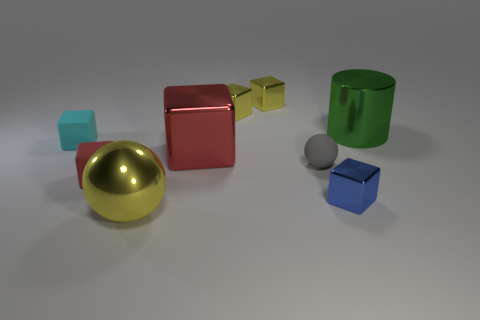There is a object that is the same color as the big cube; what shape is it?
Your answer should be compact. Cube. Is the number of red things that are on the right side of the green object less than the number of large green things in front of the tiny blue shiny object?
Your answer should be compact. No. What number of other objects are the same material as the green thing?
Ensure brevity in your answer.  5. Does the blue thing have the same material as the big green object?
Provide a short and direct response. Yes. How many other things are there of the same size as the gray thing?
Give a very brief answer. 5. What is the size of the red object that is in front of the small matte thing to the right of the small red rubber object?
Your response must be concise. Small. There is a tiny matte block that is behind the red object that is to the left of the yellow object that is in front of the big cylinder; what color is it?
Keep it short and to the point. Cyan. What is the size of the shiny object that is both on the right side of the gray sphere and behind the red matte object?
Your answer should be compact. Large. What number of other things are the same shape as the big red object?
Offer a terse response. 5. How many cylinders are either small gray rubber objects or small cyan objects?
Provide a short and direct response. 0. 